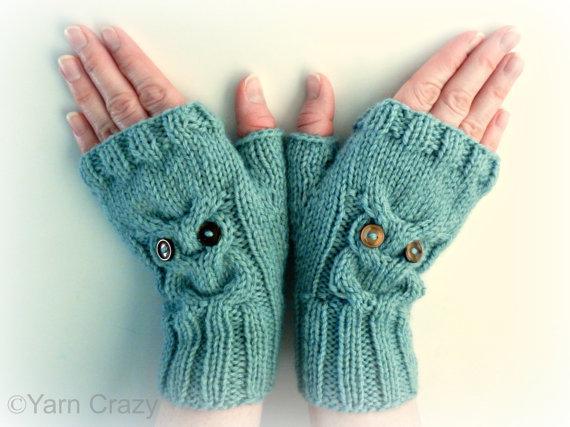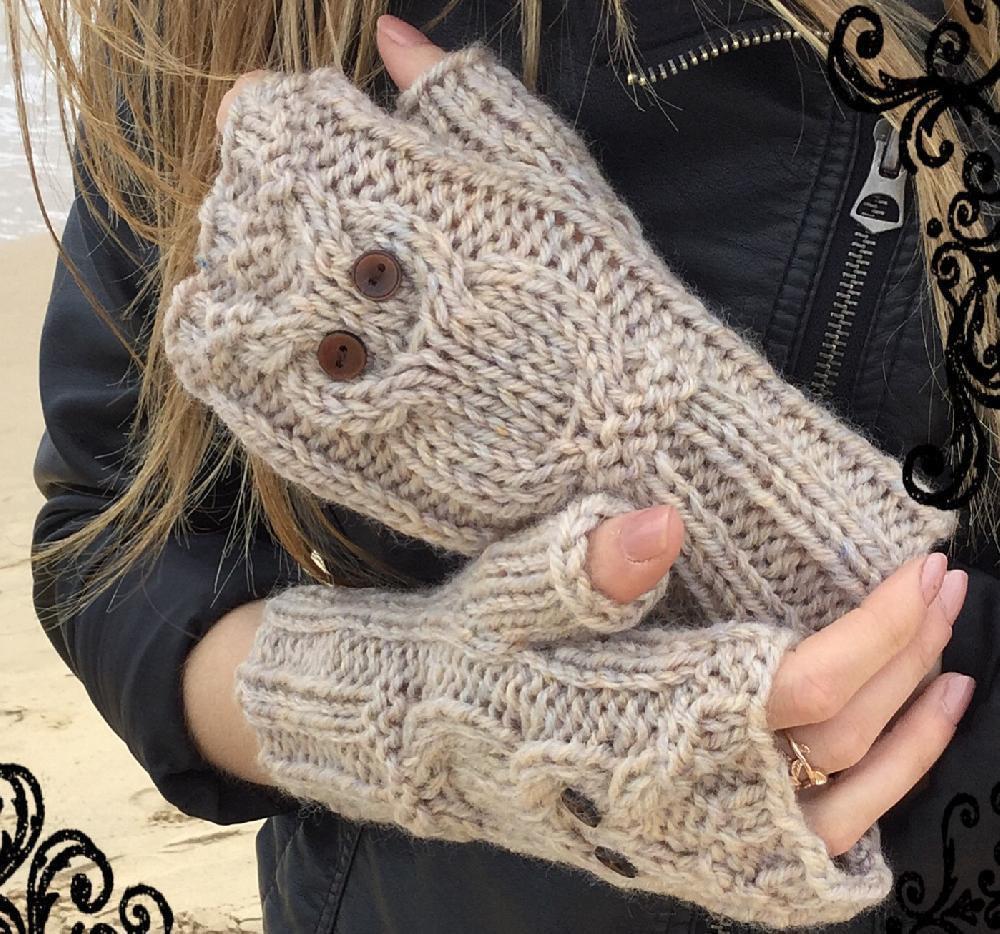The first image is the image on the left, the second image is the image on the right. For the images shown, is this caption "Four hands have gloves on them." true? Answer yes or no. Yes. 